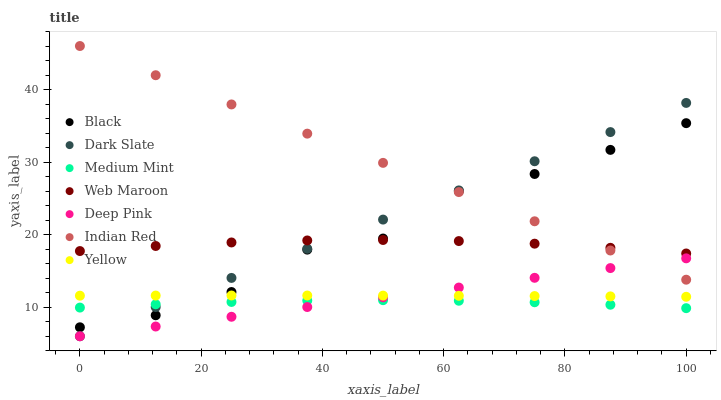Does Medium Mint have the minimum area under the curve?
Answer yes or no. Yes. Does Indian Red have the maximum area under the curve?
Answer yes or no. Yes. Does Deep Pink have the minimum area under the curve?
Answer yes or no. No. Does Deep Pink have the maximum area under the curve?
Answer yes or no. No. Is Deep Pink the smoothest?
Answer yes or no. Yes. Is Black the roughest?
Answer yes or no. Yes. Is Web Maroon the smoothest?
Answer yes or no. No. Is Web Maroon the roughest?
Answer yes or no. No. Does Deep Pink have the lowest value?
Answer yes or no. Yes. Does Web Maroon have the lowest value?
Answer yes or no. No. Does Indian Red have the highest value?
Answer yes or no. Yes. Does Deep Pink have the highest value?
Answer yes or no. No. Is Yellow less than Web Maroon?
Answer yes or no. Yes. Is Indian Red greater than Yellow?
Answer yes or no. Yes. Does Indian Red intersect Black?
Answer yes or no. Yes. Is Indian Red less than Black?
Answer yes or no. No. Is Indian Red greater than Black?
Answer yes or no. No. Does Yellow intersect Web Maroon?
Answer yes or no. No. 